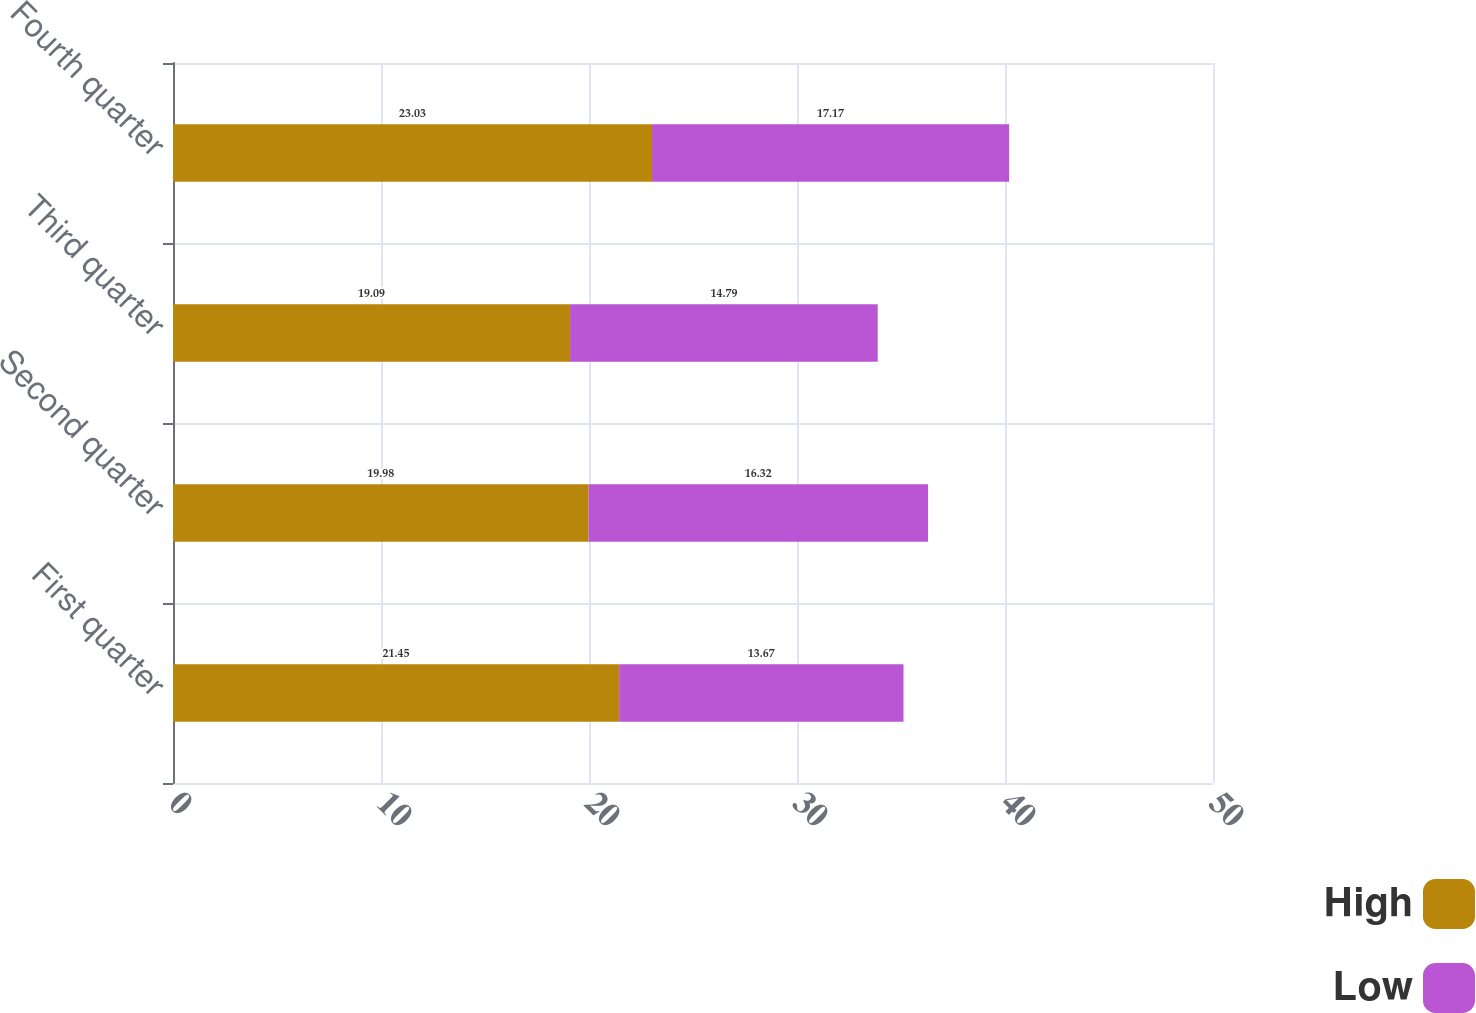Convert chart. <chart><loc_0><loc_0><loc_500><loc_500><stacked_bar_chart><ecel><fcel>First quarter<fcel>Second quarter<fcel>Third quarter<fcel>Fourth quarter<nl><fcel>High<fcel>21.45<fcel>19.98<fcel>19.09<fcel>23.03<nl><fcel>Low<fcel>13.67<fcel>16.32<fcel>14.79<fcel>17.17<nl></chart> 